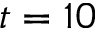<formula> <loc_0><loc_0><loc_500><loc_500>t = 1 0</formula> 